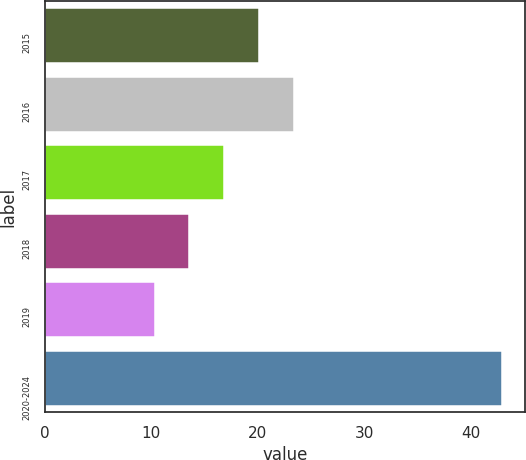<chart> <loc_0><loc_0><loc_500><loc_500><bar_chart><fcel>2015<fcel>2016<fcel>2017<fcel>2018<fcel>2019<fcel>2020-2024<nl><fcel>20.08<fcel>23.34<fcel>16.82<fcel>13.56<fcel>10.3<fcel>42.9<nl></chart> 